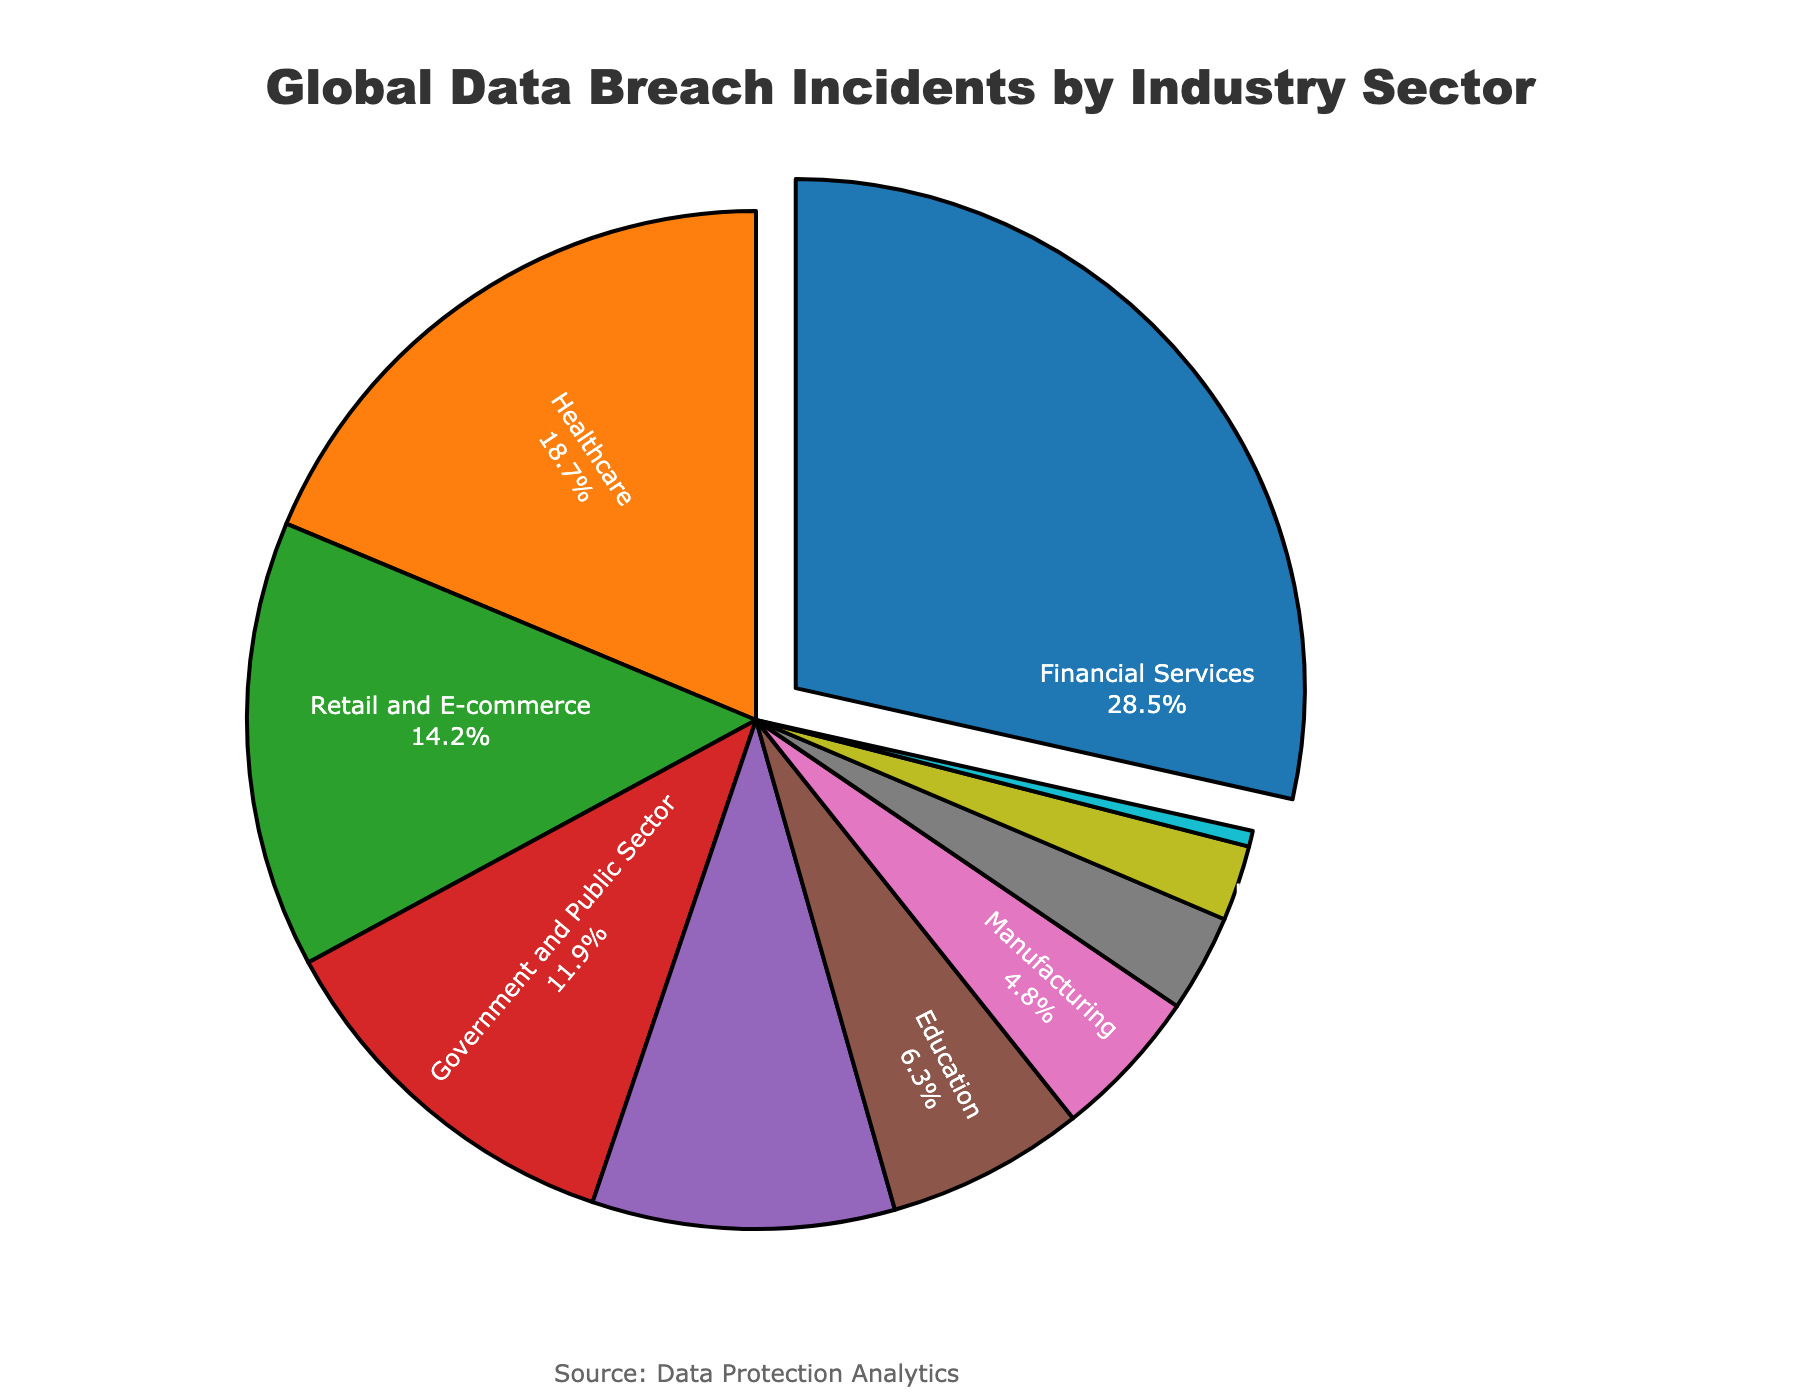What percentage of breaches does the Financial Services sector account for? The figure shows that each industry sector is labeled with its respective percentage. Locate the slice labeled "Financial Services" and note the percentage.
Answer: 28.5% Which sector has the second highest percentage of breaches? Observe the pie chart and identify the sector with the second largest slice. The Healthcare sector is the second largest.
Answer: Healthcare What is the combined percentage of breaches for the Education and Government and Public Sector? Find the percentages for Education (6.3%) and Government and Public Sector (11.9%). Add these values together: 6.3 + 11.9 = 18.2%.
Answer: 18.2% How does the percentage of breaches in Retail and E-commerce compare to the percentage in Technology and Telecommunications? Compare the percentages directly from the chart: Retail and E-commerce has 14.2% while Technology and Telecommunications has 9.6%. 14.2% is greater than 9.6%.
Answer: Retail and E-commerce has a higher percentage What is the total percentage of breaches for the top three sectors? The top three sectors are Financial Services, Healthcare, and Retail and E-commerce. Sum their percentages: 28.5 + 18.7 + 14.2 = 61.4%.
Answer: 61.4% Which sector has the smallest percentage of breaches, and what is that percentage? Identify the smallest slice in the pie chart, which corresponds to Hospitality and Tourism, and note the percentage.
Answer: Hospitality and Tourism, 0.5% What is the difference between the percentages of breaches in Manufacturing and Energy and Utilities? Subtract the percentage of Energy and Utilities from Manufacturing: 4.8 - 3.1 = 1.7%.
Answer: 1.7% Which colored slice in the chart represents the Healthcare sector? Observe the pie chart and identify the color of the slice labeled "Healthcare". It is the second sector and typically a distinctive color, such as orange.
Answer: Orange Are breaches in the Government and Public Sector higher than in Education? Compare the percentages for Government and Public Sector (11.9%) and Education (6.3%). Yes, 11.9% is higher than 6.3%.
Answer: Yes What is the average percentage of breaches among the bottom five sectors? Identify the bottom five sectors: Professional Services, Energy and Utilities, Manufacturing, Education, and Hospitality and Tourism. Calculate their average: (2.4 + 3.1 + 4.8 + 6.3 + 0.5) / 5 = 3.42%.
Answer: 3.42% 